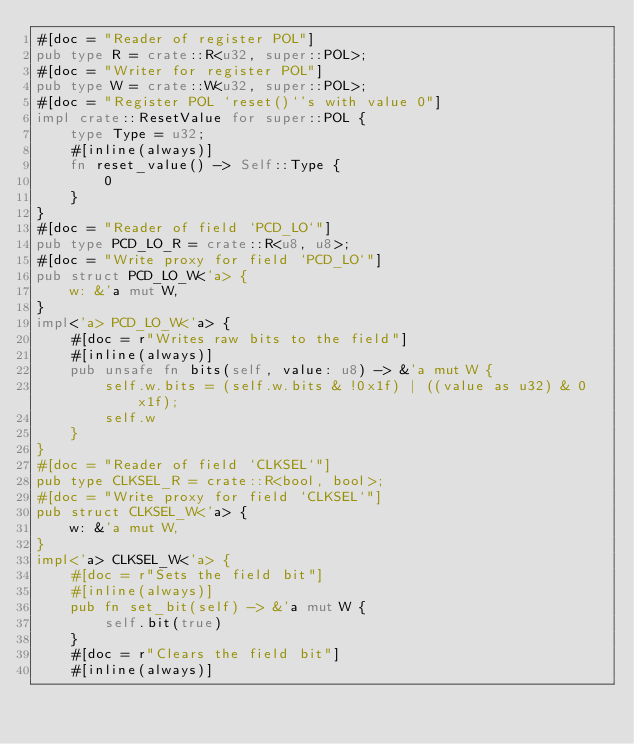<code> <loc_0><loc_0><loc_500><loc_500><_Rust_>#[doc = "Reader of register POL"]
pub type R = crate::R<u32, super::POL>;
#[doc = "Writer for register POL"]
pub type W = crate::W<u32, super::POL>;
#[doc = "Register POL `reset()`'s with value 0"]
impl crate::ResetValue for super::POL {
    type Type = u32;
    #[inline(always)]
    fn reset_value() -> Self::Type {
        0
    }
}
#[doc = "Reader of field `PCD_LO`"]
pub type PCD_LO_R = crate::R<u8, u8>;
#[doc = "Write proxy for field `PCD_LO`"]
pub struct PCD_LO_W<'a> {
    w: &'a mut W,
}
impl<'a> PCD_LO_W<'a> {
    #[doc = r"Writes raw bits to the field"]
    #[inline(always)]
    pub unsafe fn bits(self, value: u8) -> &'a mut W {
        self.w.bits = (self.w.bits & !0x1f) | ((value as u32) & 0x1f);
        self.w
    }
}
#[doc = "Reader of field `CLKSEL`"]
pub type CLKSEL_R = crate::R<bool, bool>;
#[doc = "Write proxy for field `CLKSEL`"]
pub struct CLKSEL_W<'a> {
    w: &'a mut W,
}
impl<'a> CLKSEL_W<'a> {
    #[doc = r"Sets the field bit"]
    #[inline(always)]
    pub fn set_bit(self) -> &'a mut W {
        self.bit(true)
    }
    #[doc = r"Clears the field bit"]
    #[inline(always)]</code> 